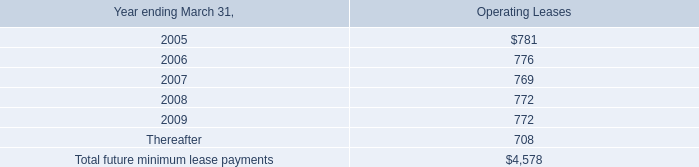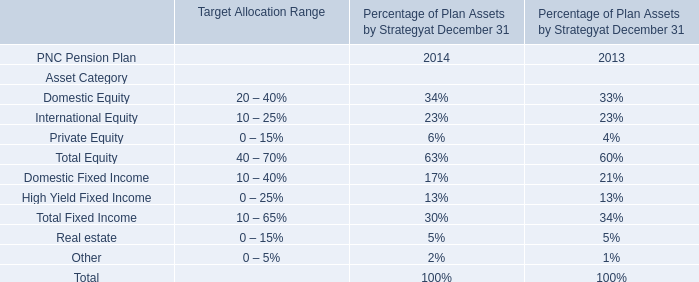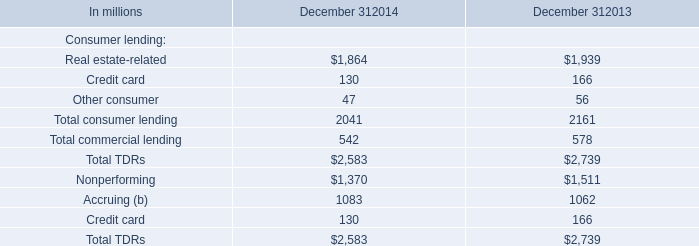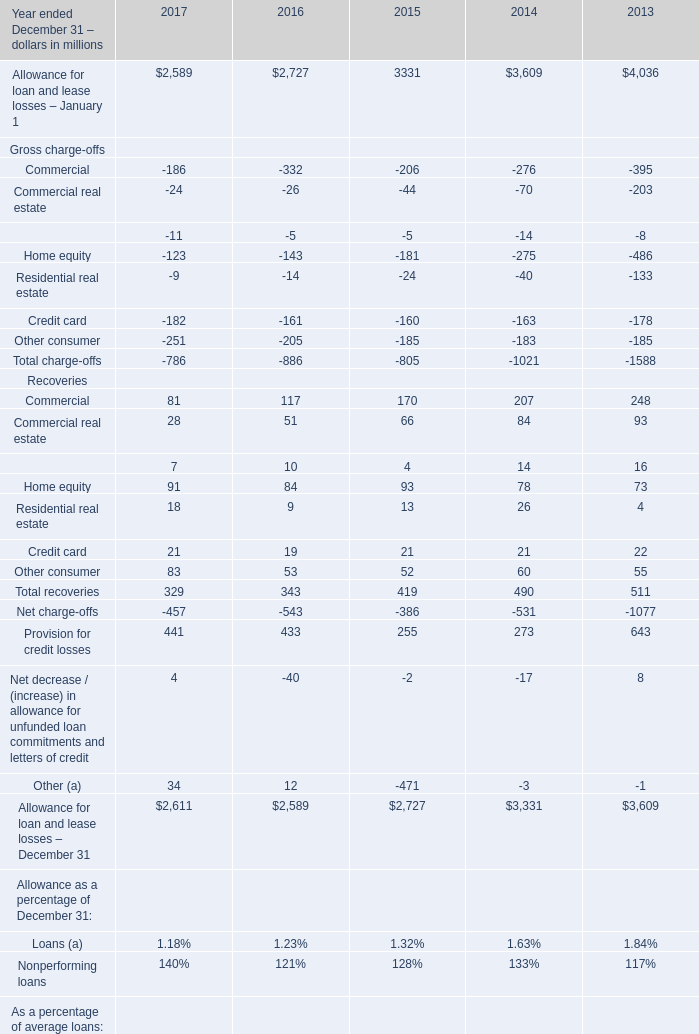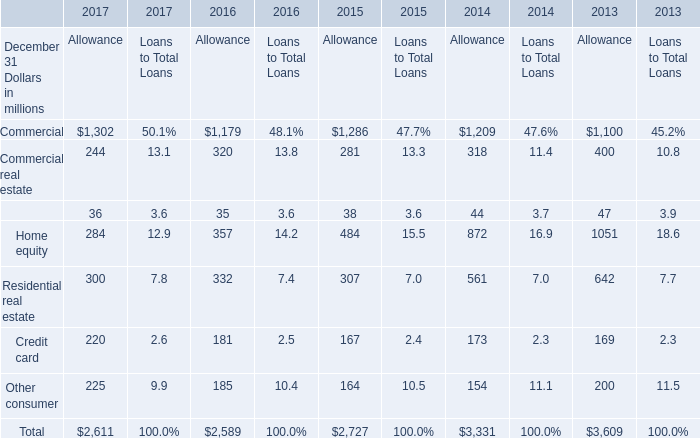In the year with the most Home equity for Recoveries, what is the growth rate of Commercial for Recoveries ? 
Computations: ((170 - 207) / 207)
Answer: -0.17874. 